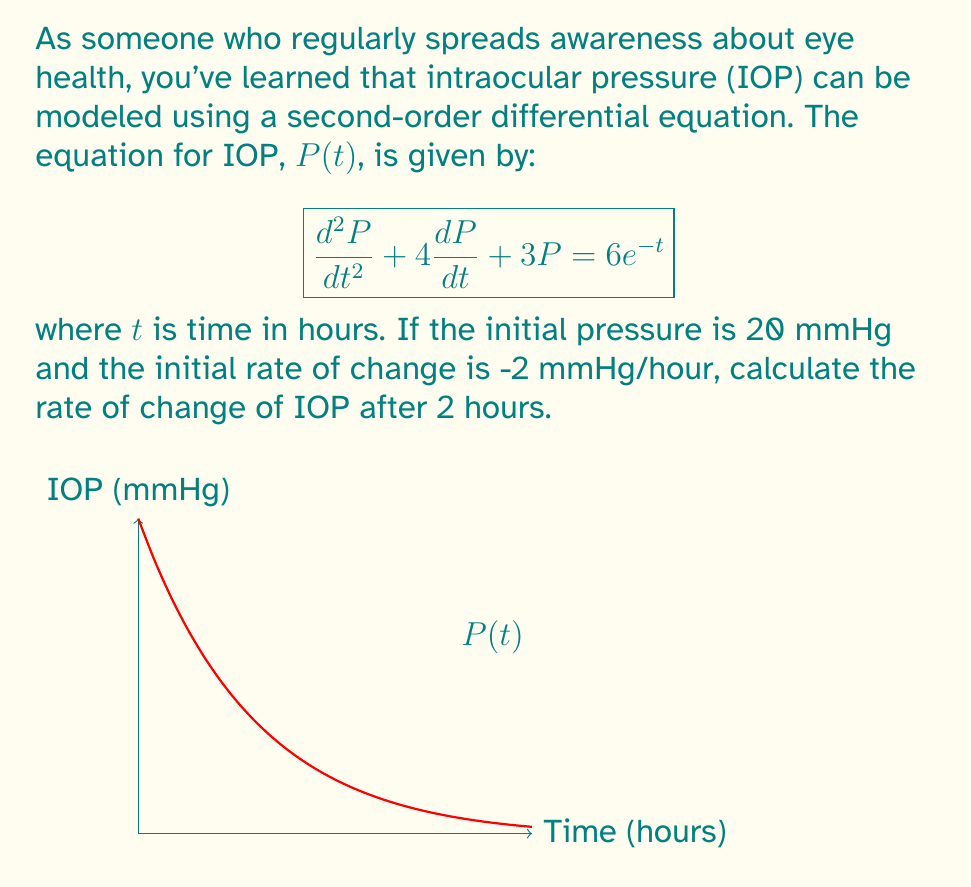What is the answer to this math problem? Let's approach this step-by-step:

1) We have a second-order linear differential equation:
   $$\frac{d^2P}{dt^2} + 4\frac{dP}{dt} + 3P = 6e^{-t}$$

2) We're given two initial conditions:
   $P(0) = 20$ (initial pressure)
   $P'(0) = -2$ (initial rate of change)

3) To find the rate of change at t = 2, we need to solve for $P(t)$ and then find $P'(2)$.

4) The general solution for this equation is:
   $$P(t) = c_1e^{-t} + c_2e^{-3t} + 2e^{-t}$$

5) Using the initial conditions:
   $P(0) = c_1 + c_2 + 2 = 20$
   $P'(0) = -c_1 - 3c_2 - 2 = -2$

6) Solving these equations:
   $c_1 = 20$
   $c_2 = -2$

7) Therefore, the particular solution is:
   $$P(t) = 20e^{-t} - 2e^{-3t} + 2e^{-t}$$

8) To find the rate of change, we differentiate:
   $$P'(t) = -20e^{-t} + 6e^{-3t} - 2e^{-t}$$

9) Evaluating at t = 2:
   $$P'(2) = -20e^{-2} + 6e^{-6} - 2e^{-2}$$

10) Calculating this value:
    $$P'(2) \approx -3.03 \text{ mmHg/hour}$$
Answer: $-3.03 \text{ mmHg/hour}$ 